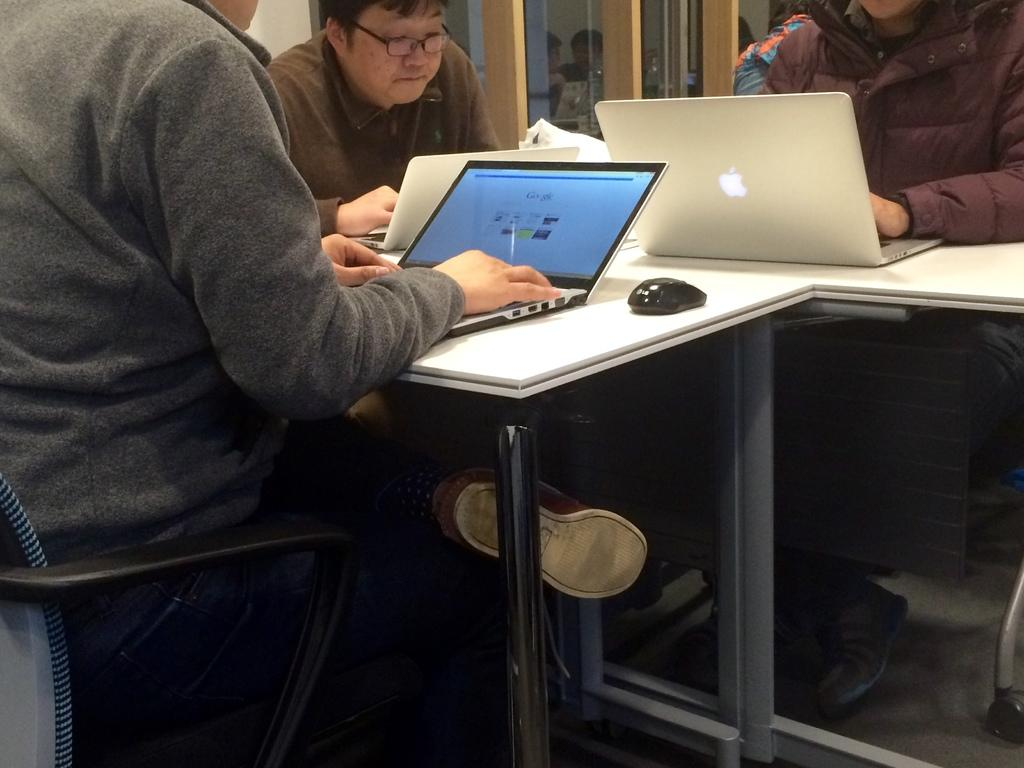What are the persons in the image doing? The persons in the image are sitting in the chair and working on laptops. Where are the laptops located? The laptops are present on a table. What is used to interact with the laptops? There is a mouse associated with the laptops. What type of scent can be detected from the list in the image? There is no list present in the image, and therefore no scent can be detected from it. 